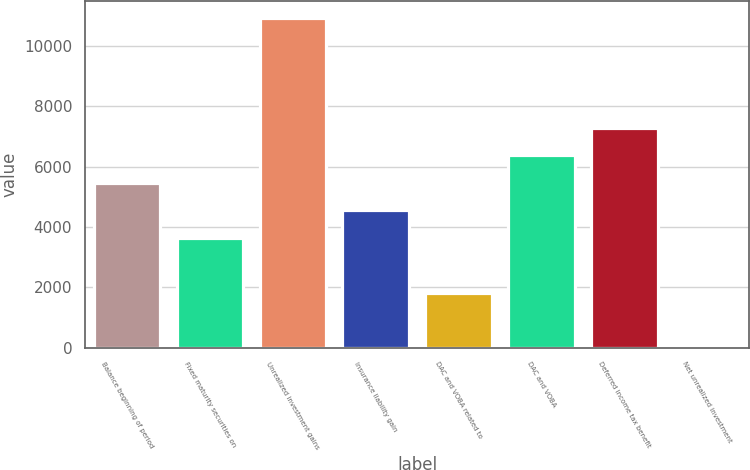Convert chart to OTSL. <chart><loc_0><loc_0><loc_500><loc_500><bar_chart><fcel>Balance beginning of period<fcel>Fixed maturity securities on<fcel>Unrealized investment gains<fcel>Insurance liability gain<fcel>DAC and VOBA related to<fcel>DAC and VOBA<fcel>Deferred income tax benefit<fcel>Net unrealized investment<nl><fcel>5471.4<fcel>3648.6<fcel>10939.8<fcel>4560<fcel>1825.8<fcel>6382.8<fcel>7294.2<fcel>3<nl></chart> 